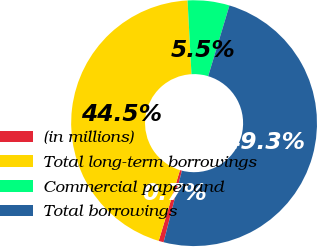Convert chart. <chart><loc_0><loc_0><loc_500><loc_500><pie_chart><fcel>(in millions)<fcel>Total long-term borrowings<fcel>Commercial paper and<fcel>Total borrowings<nl><fcel>0.66%<fcel>44.51%<fcel>5.49%<fcel>49.34%<nl></chart> 